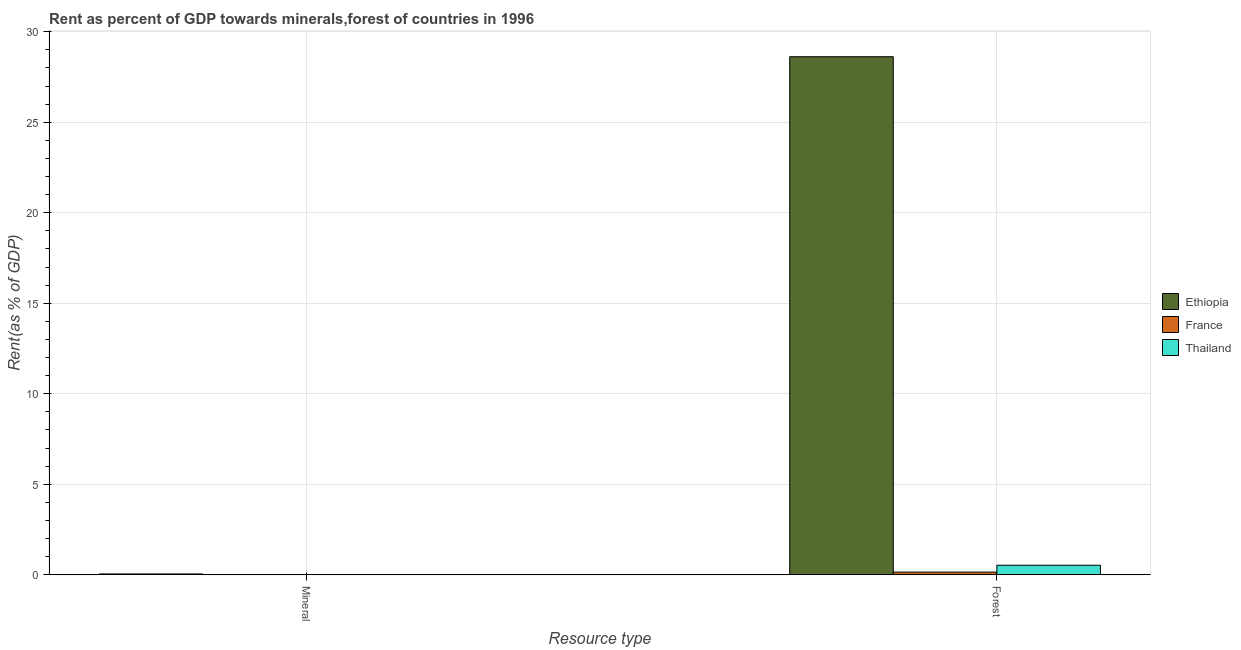How many different coloured bars are there?
Offer a terse response. 3. How many groups of bars are there?
Your answer should be very brief. 2. Are the number of bars per tick equal to the number of legend labels?
Your answer should be compact. Yes. What is the label of the 2nd group of bars from the left?
Offer a terse response. Forest. What is the mineral rent in France?
Your response must be concise. 0. Across all countries, what is the maximum forest rent?
Your answer should be very brief. 28.62. Across all countries, what is the minimum mineral rent?
Your answer should be very brief. 0. In which country was the mineral rent maximum?
Ensure brevity in your answer.  Ethiopia. In which country was the mineral rent minimum?
Offer a very short reply. France. What is the total forest rent in the graph?
Make the answer very short. 29.29. What is the difference between the forest rent in Thailand and that in Ethiopia?
Give a very brief answer. -28.1. What is the difference between the forest rent in France and the mineral rent in Ethiopia?
Provide a succinct answer. 0.1. What is the average mineral rent per country?
Provide a succinct answer. 0.02. What is the difference between the forest rent and mineral rent in Thailand?
Give a very brief answer. 0.52. What is the ratio of the mineral rent in France to that in Thailand?
Your response must be concise. 0.13. In how many countries, is the forest rent greater than the average forest rent taken over all countries?
Give a very brief answer. 1. What does the 3rd bar from the left in Forest represents?
Make the answer very short. Thailand. What does the 3rd bar from the right in Forest represents?
Your answer should be very brief. Ethiopia. Are all the bars in the graph horizontal?
Make the answer very short. No. How many countries are there in the graph?
Your answer should be very brief. 3. What is the difference between two consecutive major ticks on the Y-axis?
Your answer should be compact. 5. Are the values on the major ticks of Y-axis written in scientific E-notation?
Offer a very short reply. No. Does the graph contain any zero values?
Offer a very short reply. No. Does the graph contain grids?
Your answer should be very brief. Yes. Where does the legend appear in the graph?
Make the answer very short. Center right. How many legend labels are there?
Provide a succinct answer. 3. How are the legend labels stacked?
Offer a terse response. Vertical. What is the title of the graph?
Your response must be concise. Rent as percent of GDP towards minerals,forest of countries in 1996. What is the label or title of the X-axis?
Make the answer very short. Resource type. What is the label or title of the Y-axis?
Keep it short and to the point. Rent(as % of GDP). What is the Rent(as % of GDP) of Ethiopia in Mineral?
Keep it short and to the point. 0.04. What is the Rent(as % of GDP) of France in Mineral?
Your answer should be compact. 0. What is the Rent(as % of GDP) of Thailand in Mineral?
Provide a short and direct response. 0. What is the Rent(as % of GDP) of Ethiopia in Forest?
Your answer should be compact. 28.62. What is the Rent(as % of GDP) in France in Forest?
Give a very brief answer. 0.14. What is the Rent(as % of GDP) in Thailand in Forest?
Your response must be concise. 0.52. Across all Resource type, what is the maximum Rent(as % of GDP) in Ethiopia?
Offer a very short reply. 28.62. Across all Resource type, what is the maximum Rent(as % of GDP) of France?
Your response must be concise. 0.14. Across all Resource type, what is the maximum Rent(as % of GDP) in Thailand?
Your answer should be compact. 0.52. Across all Resource type, what is the minimum Rent(as % of GDP) of Ethiopia?
Offer a terse response. 0.04. Across all Resource type, what is the minimum Rent(as % of GDP) of France?
Ensure brevity in your answer.  0. Across all Resource type, what is the minimum Rent(as % of GDP) in Thailand?
Provide a short and direct response. 0. What is the total Rent(as % of GDP) in Ethiopia in the graph?
Ensure brevity in your answer.  28.66. What is the total Rent(as % of GDP) in France in the graph?
Offer a very short reply. 0.14. What is the total Rent(as % of GDP) of Thailand in the graph?
Offer a very short reply. 0.53. What is the difference between the Rent(as % of GDP) of Ethiopia in Mineral and that in Forest?
Provide a short and direct response. -28.58. What is the difference between the Rent(as % of GDP) in France in Mineral and that in Forest?
Offer a terse response. -0.14. What is the difference between the Rent(as % of GDP) of Thailand in Mineral and that in Forest?
Your answer should be compact. -0.52. What is the difference between the Rent(as % of GDP) in Ethiopia in Mineral and the Rent(as % of GDP) in France in Forest?
Ensure brevity in your answer.  -0.1. What is the difference between the Rent(as % of GDP) in Ethiopia in Mineral and the Rent(as % of GDP) in Thailand in Forest?
Give a very brief answer. -0.48. What is the difference between the Rent(as % of GDP) of France in Mineral and the Rent(as % of GDP) of Thailand in Forest?
Offer a very short reply. -0.52. What is the average Rent(as % of GDP) of Ethiopia per Resource type?
Ensure brevity in your answer.  14.33. What is the average Rent(as % of GDP) of France per Resource type?
Provide a succinct answer. 0.07. What is the average Rent(as % of GDP) in Thailand per Resource type?
Provide a short and direct response. 0.26. What is the difference between the Rent(as % of GDP) of Ethiopia and Rent(as % of GDP) of France in Mineral?
Your answer should be compact. 0.04. What is the difference between the Rent(as % of GDP) in Ethiopia and Rent(as % of GDP) in Thailand in Mineral?
Offer a very short reply. 0.04. What is the difference between the Rent(as % of GDP) in France and Rent(as % of GDP) in Thailand in Mineral?
Give a very brief answer. -0. What is the difference between the Rent(as % of GDP) of Ethiopia and Rent(as % of GDP) of France in Forest?
Ensure brevity in your answer.  28.48. What is the difference between the Rent(as % of GDP) in Ethiopia and Rent(as % of GDP) in Thailand in Forest?
Make the answer very short. 28.1. What is the difference between the Rent(as % of GDP) of France and Rent(as % of GDP) of Thailand in Forest?
Your answer should be very brief. -0.38. What is the ratio of the Rent(as % of GDP) in Ethiopia in Mineral to that in Forest?
Your answer should be compact. 0. What is the ratio of the Rent(as % of GDP) in France in Mineral to that in Forest?
Your answer should be compact. 0. What is the ratio of the Rent(as % of GDP) in Thailand in Mineral to that in Forest?
Your response must be concise. 0.01. What is the difference between the highest and the second highest Rent(as % of GDP) of Ethiopia?
Your answer should be very brief. 28.58. What is the difference between the highest and the second highest Rent(as % of GDP) in France?
Your response must be concise. 0.14. What is the difference between the highest and the second highest Rent(as % of GDP) of Thailand?
Your answer should be very brief. 0.52. What is the difference between the highest and the lowest Rent(as % of GDP) in Ethiopia?
Provide a succinct answer. 28.58. What is the difference between the highest and the lowest Rent(as % of GDP) in France?
Keep it short and to the point. 0.14. What is the difference between the highest and the lowest Rent(as % of GDP) in Thailand?
Give a very brief answer. 0.52. 